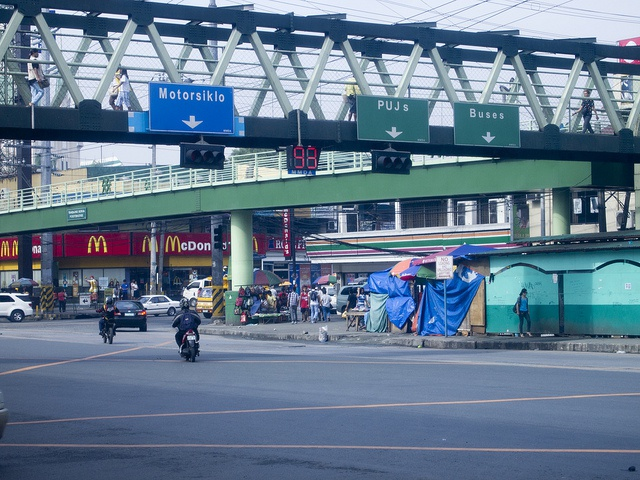Describe the objects in this image and their specific colors. I can see people in navy, lavender, darkgray, and gray tones, traffic light in navy, darkblue, and blue tones, traffic light in navy, blue, and gray tones, car in navy, black, gray, and blue tones, and car in navy, lightgray, darkgray, and gray tones in this image. 